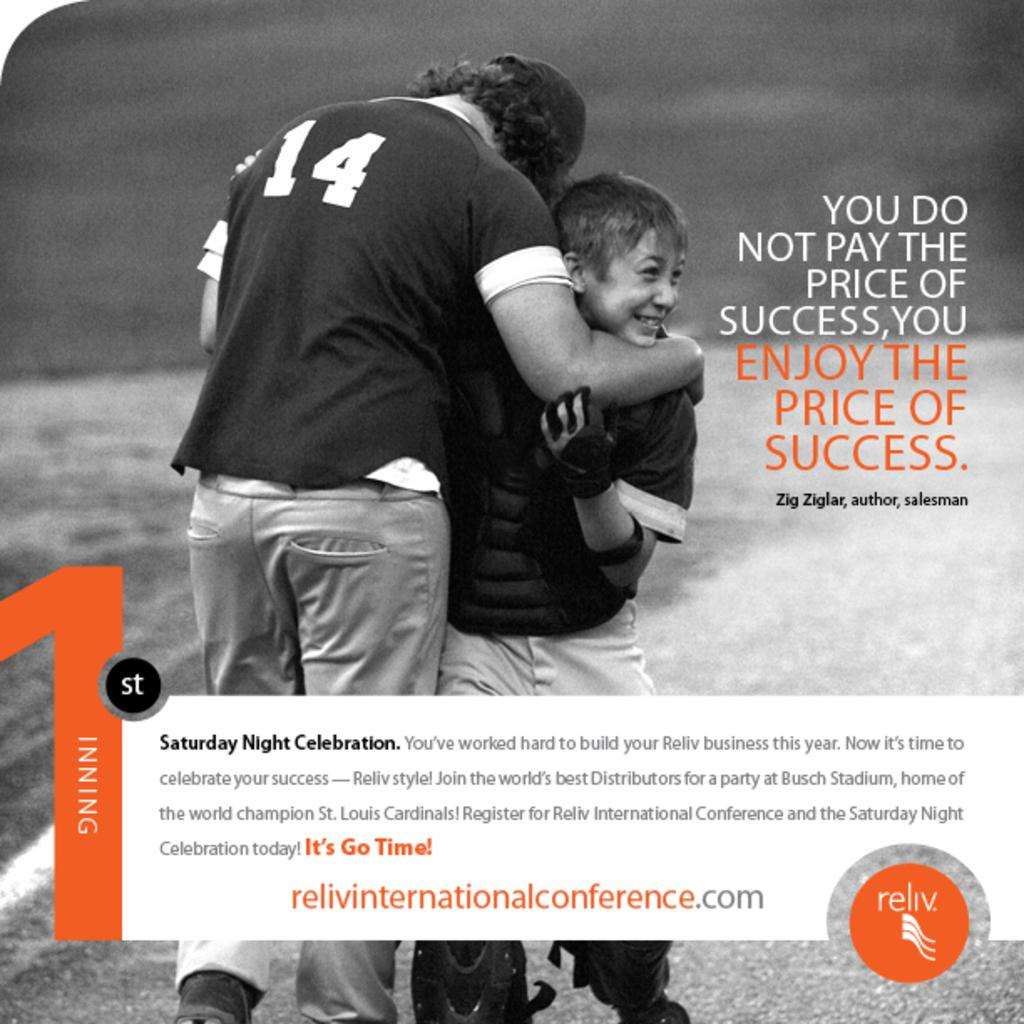What is the color scheme of the image? The image is black and white. What can be seen in the image besides the color scheme? There is a poster in the image. What is depicted on the poster? The poster contains two persons. Is there any text on the poster? Yes, there is text on the poster. What type of liquid is being poured on the books in the image? There are no books or liquid present in the image; it only features a black and white poster with two persons and text. 